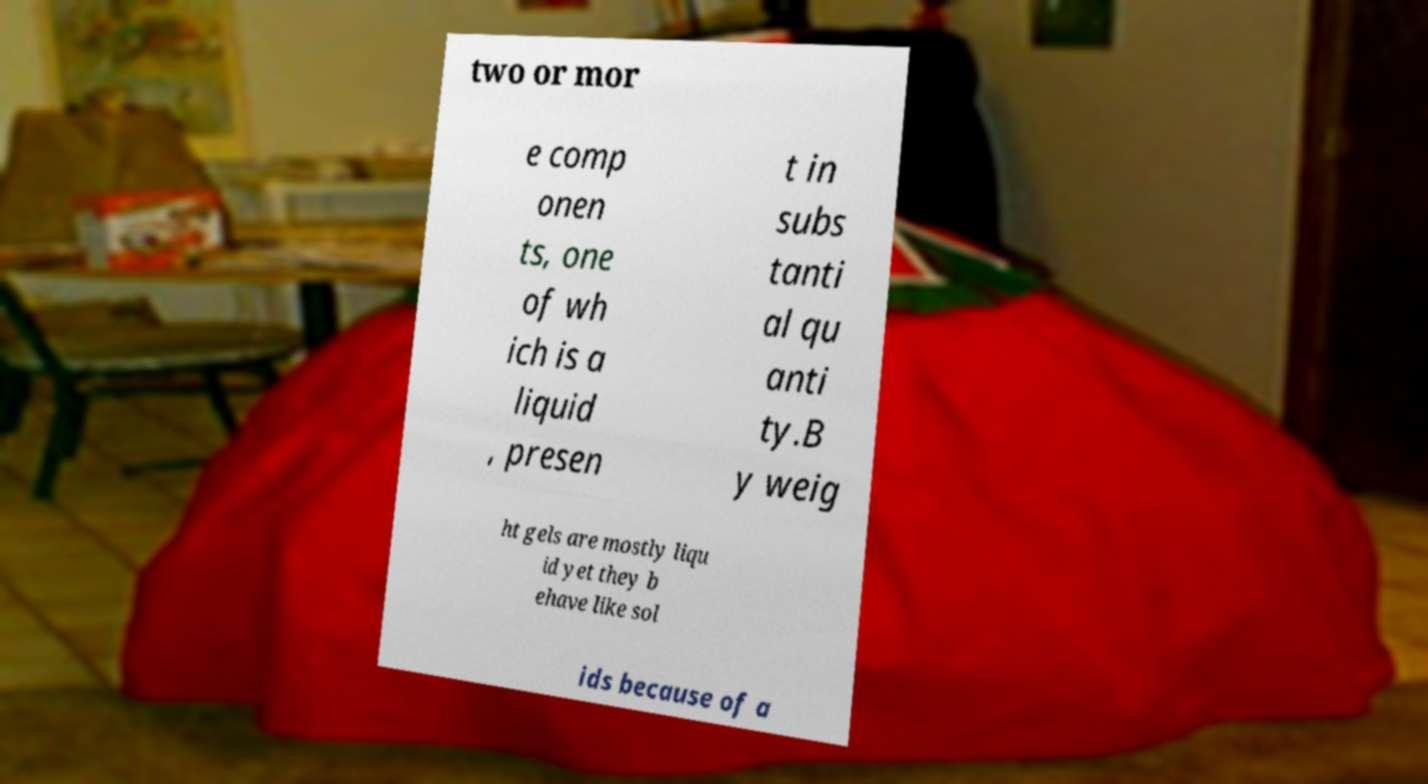For documentation purposes, I need the text within this image transcribed. Could you provide that? two or mor e comp onen ts, one of wh ich is a liquid , presen t in subs tanti al qu anti ty.B y weig ht gels are mostly liqu id yet they b ehave like sol ids because of a 